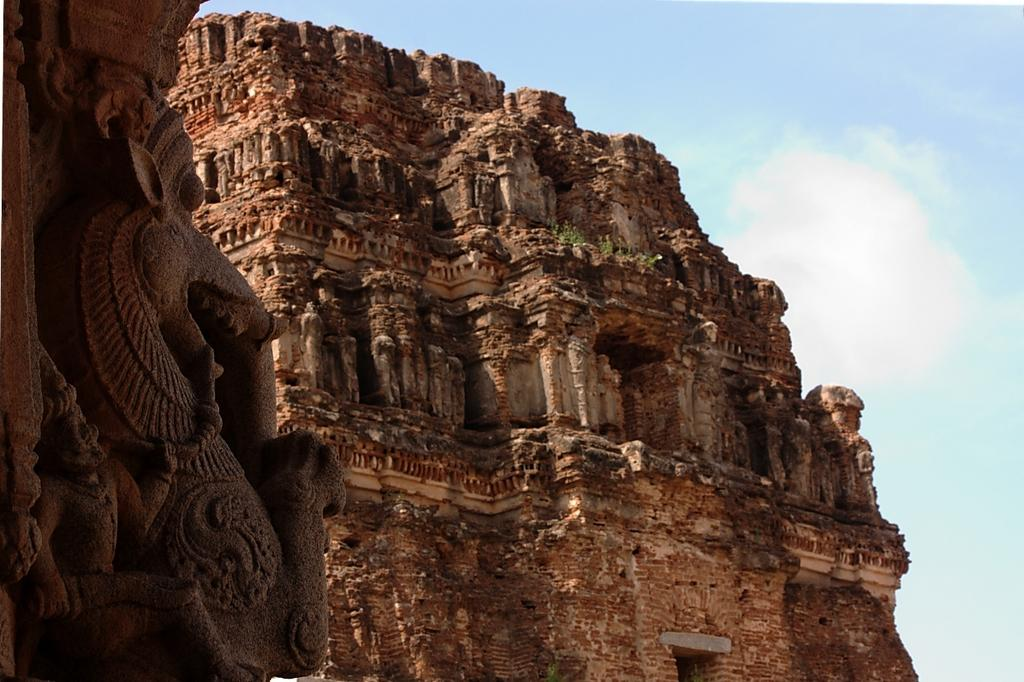What type of structure is present in the image? There is a building in the image. What is the color of the building? The building is brown in color. What can be seen in the background of the image? There are small plants in the background of the image. What is the color of the plants? The plants are green in color. What is visible above the building and plants? The sky is visible in the image. What colors can be seen in the sky? The sky is blue and white in color. What type of apparatus is used to mix the glue in the image? There is no apparatus or glue present in the image. How many pies are visible on the building in the image? There are no pies visible on the building or anywhere in the image. 